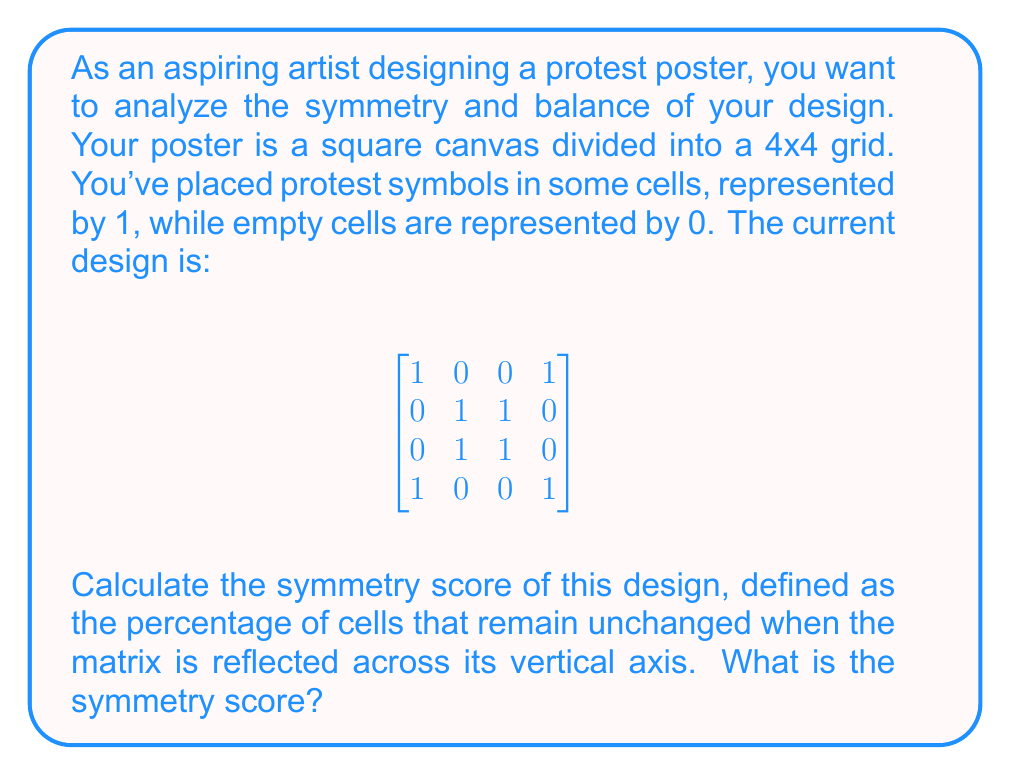Solve this math problem. To calculate the symmetry score, we need to follow these steps:

1) First, let's understand what vertical reflection means. It's like folding the matrix down the middle vertically. The left half should mirror the right half for perfect symmetry.

2) We need to compare each cell with its vertically reflected counterpart:
   - (1,1) with (1,4)
   - (2,1) with (2,4)
   - (3,1) with (3,4)
   - (4,1) with (4,4)
   - (1,2) with (1,3)
   - (2,2) with (2,3)
   - (3,2) with (3,3)
   - (4,2) with (4,3)

3) Let's count how many of these pairs match:
   - (1,1) and (1,4): 1 = 1 (match)
   - (2,1) and (2,4): 0 = 0 (match)
   - (3,1) and (3,4): 0 = 0 (match)
   - (4,1) and (4,4): 1 = 1 (match)
   - (1,2) and (1,3): 0 = 0 (match)
   - (2,2) and (2,3): 1 = 1 (match)
   - (3,2) and (3,3): 1 = 1 (match)
   - (4,2) and (4,3): 0 = 0 (match)

4) All 8 pairs match.

5) The symmetry score is the percentage of cells that remain unchanged. Since all cells remain unchanged:

   $\text{Symmetry Score} = \frac{\text{Unchanged Cells}}{\text{Total Cells}} \times 100\%$
   
   $= \frac{16}{16} \times 100\% = 100\%$

Therefore, the symmetry score of this design is 100%.
Answer: 100% 